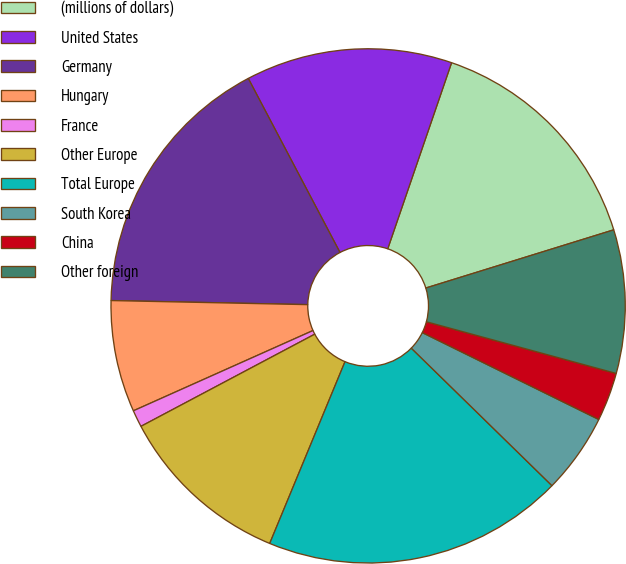Convert chart. <chart><loc_0><loc_0><loc_500><loc_500><pie_chart><fcel>(millions of dollars)<fcel>United States<fcel>Germany<fcel>Hungary<fcel>France<fcel>Other Europe<fcel>Total Europe<fcel>South Korea<fcel>China<fcel>Other foreign<nl><fcel>14.96%<fcel>12.98%<fcel>16.95%<fcel>7.02%<fcel>1.07%<fcel>10.99%<fcel>18.93%<fcel>5.04%<fcel>3.05%<fcel>9.01%<nl></chart> 